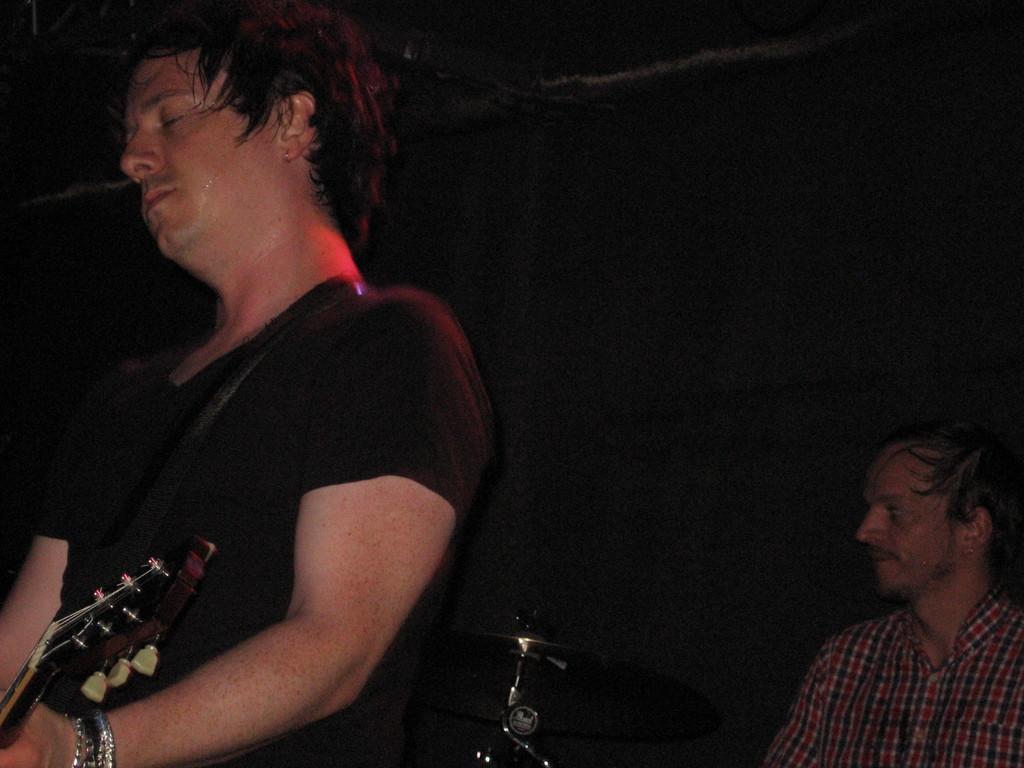Please provide a concise description of this image. In this picture there is a man holding a guitar. There is a person sitting on the chair. A musical instrument is visible. 